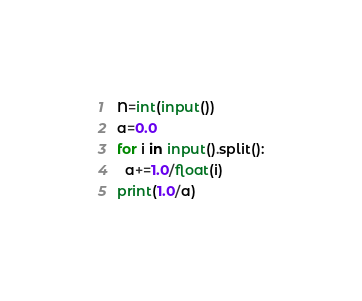Convert code to text. <code><loc_0><loc_0><loc_500><loc_500><_Python_>N=int(input())
a=0.0
for i in input().split():
  a+=1.0/float(i)
print(1.0/a)</code> 